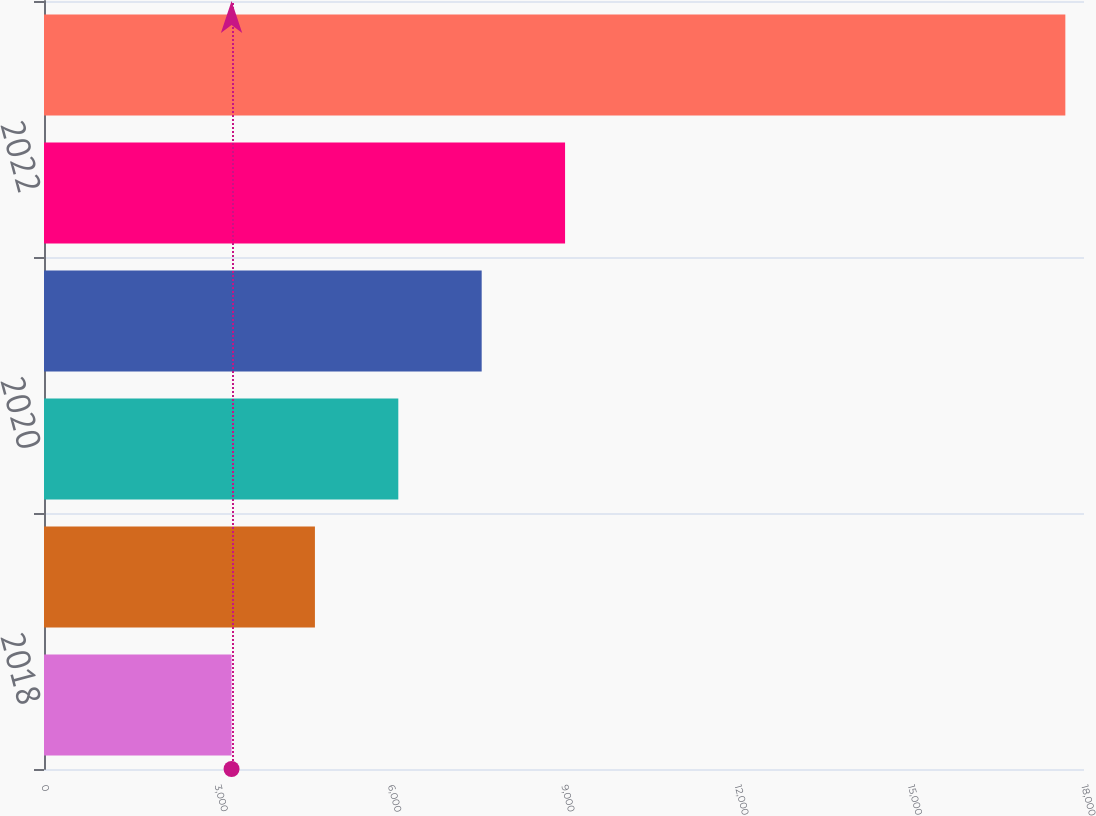<chart> <loc_0><loc_0><loc_500><loc_500><bar_chart><fcel>2018<fcel>2019<fcel>2020<fcel>2021<fcel>2022<fcel>2023 - 2027<nl><fcel>3246<fcel>4689.1<fcel>6132.2<fcel>7575.3<fcel>9018.4<fcel>17677<nl></chart> 